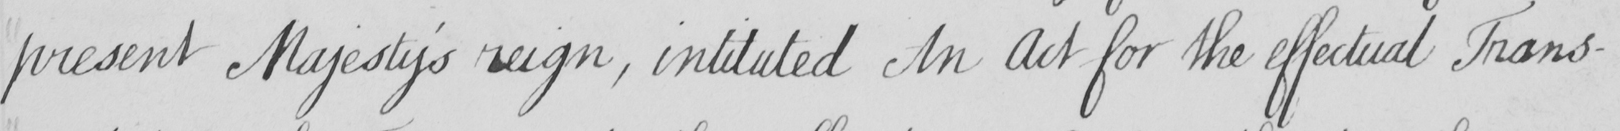Can you read and transcribe this handwriting? present Majesty ' s reign  , intituted An Act for the effectual Trans- 